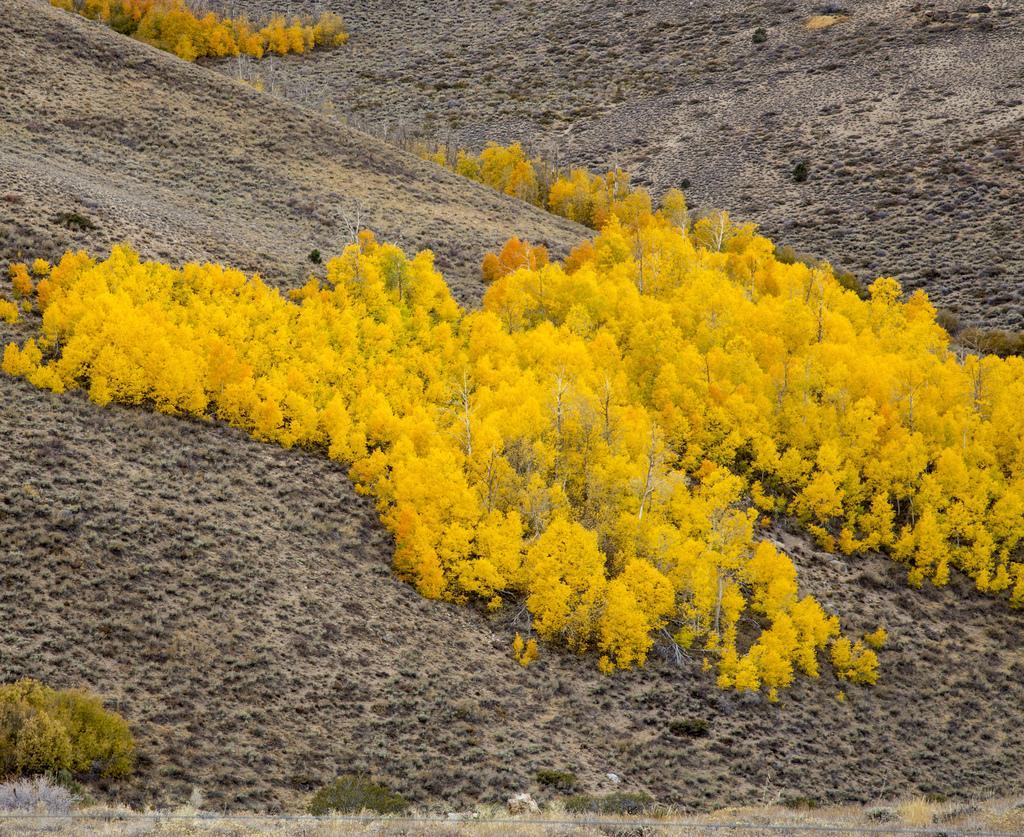In one or two sentences, can you explain what this image depicts? In this picture we can see planets, at the bottom there is soil. 